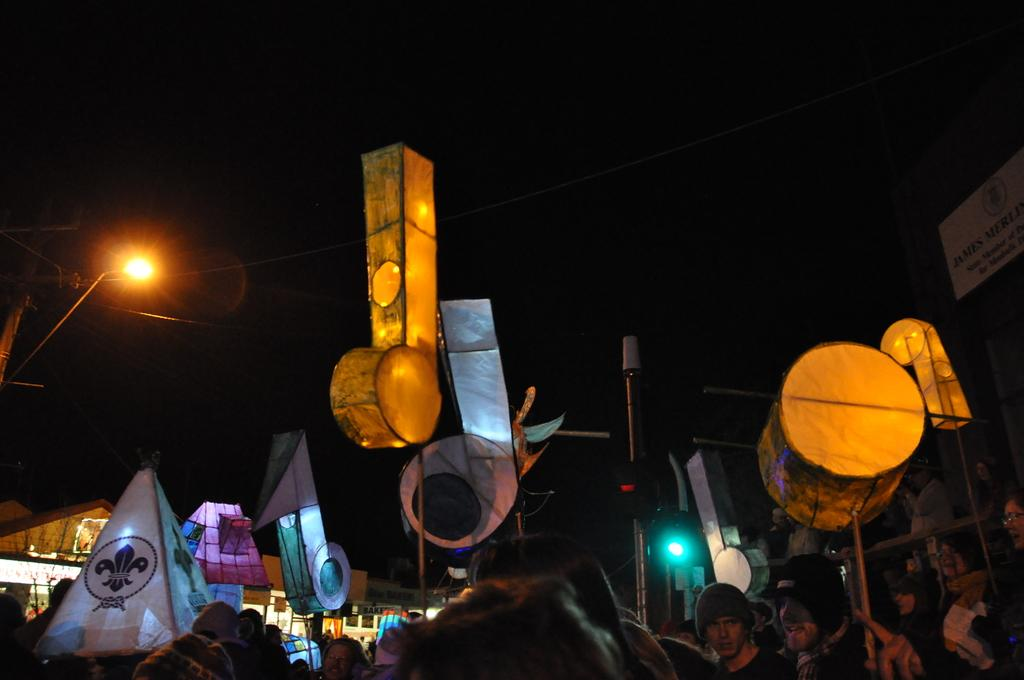What is happening in the image? There are people standing in a group in the image. What else can be seen in the image besides the people? There are objects in the image. What is the condition of the sky in the sky in the image? The sky is dark at the top of the image. What type of beetle can be seen crawling on the design in the image? There is no beetle or design present in the image. 